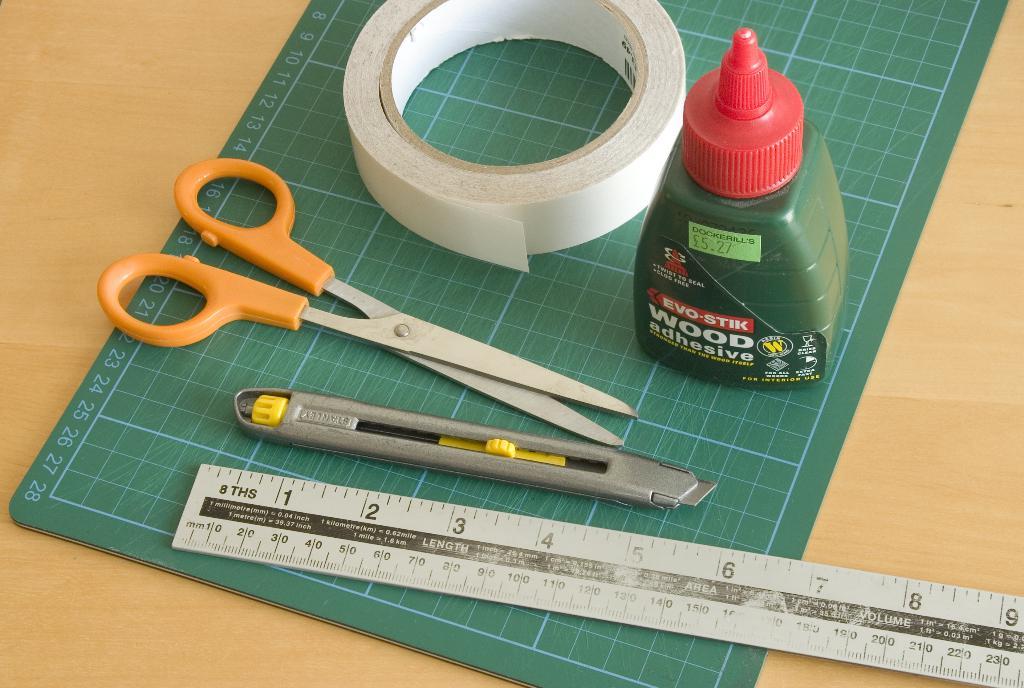What kind of adhesives is in the green bottle?
Keep it short and to the point. Wood. The kind of wood adhesive?
Offer a very short reply. Evo-stik. 